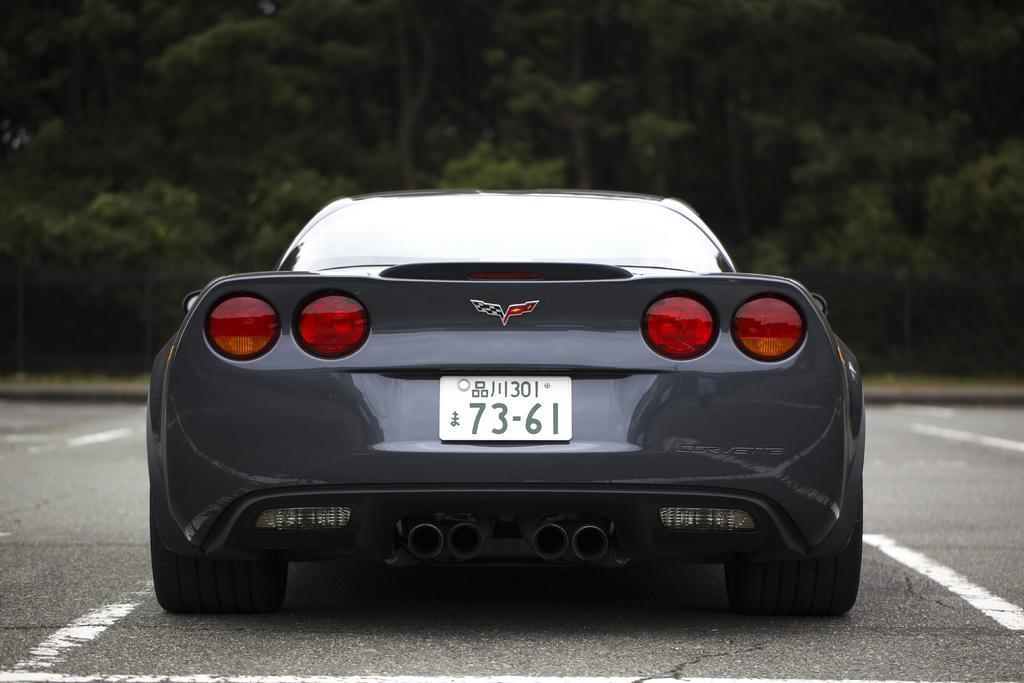<image>
Present a compact description of the photo's key features. The rear of a clean sports car with the tag number 7361. 